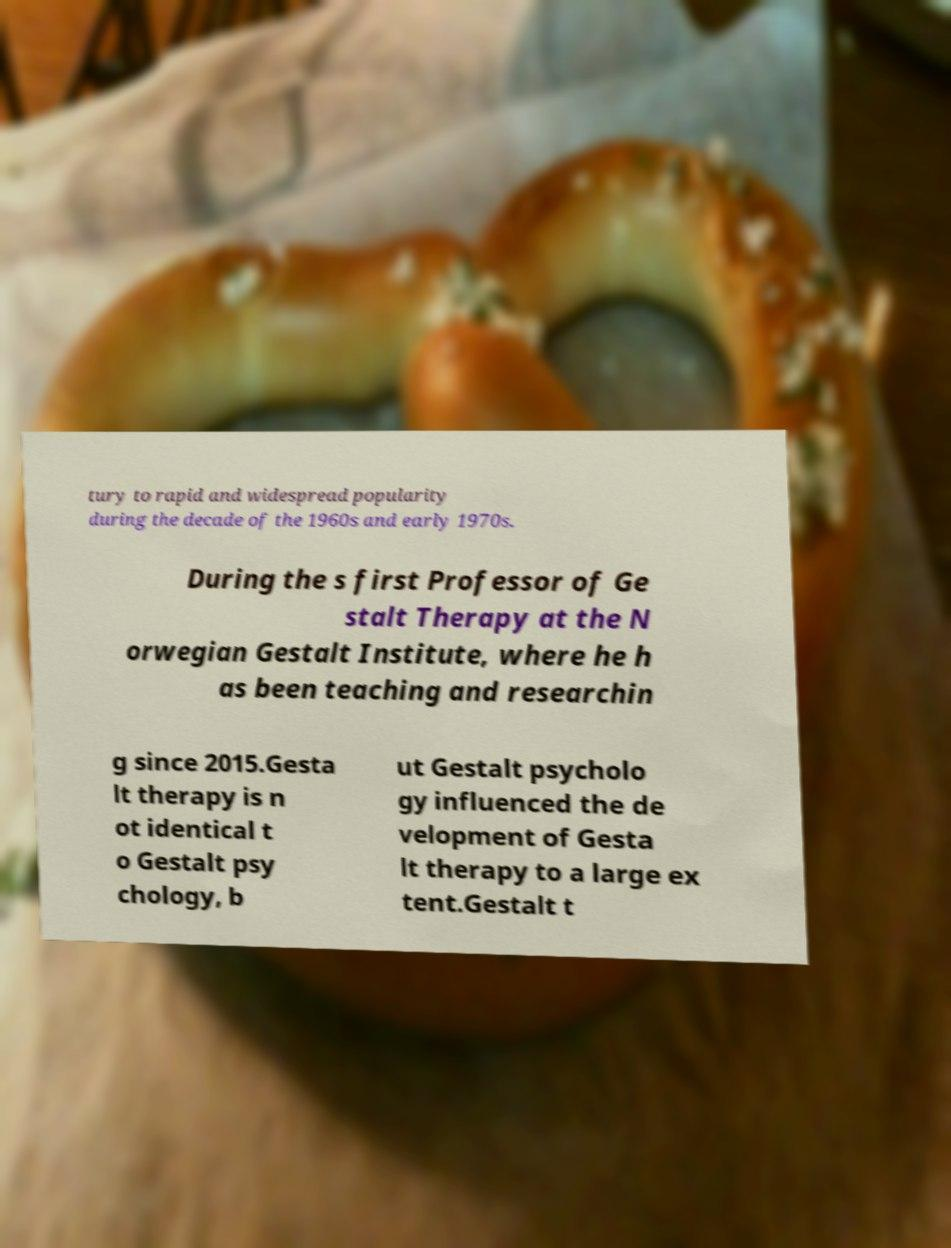Could you extract and type out the text from this image? tury to rapid and widespread popularity during the decade of the 1960s and early 1970s. During the s first Professor of Ge stalt Therapy at the N orwegian Gestalt Institute, where he h as been teaching and researchin g since 2015.Gesta lt therapy is n ot identical t o Gestalt psy chology, b ut Gestalt psycholo gy influenced the de velopment of Gesta lt therapy to a large ex tent.Gestalt t 